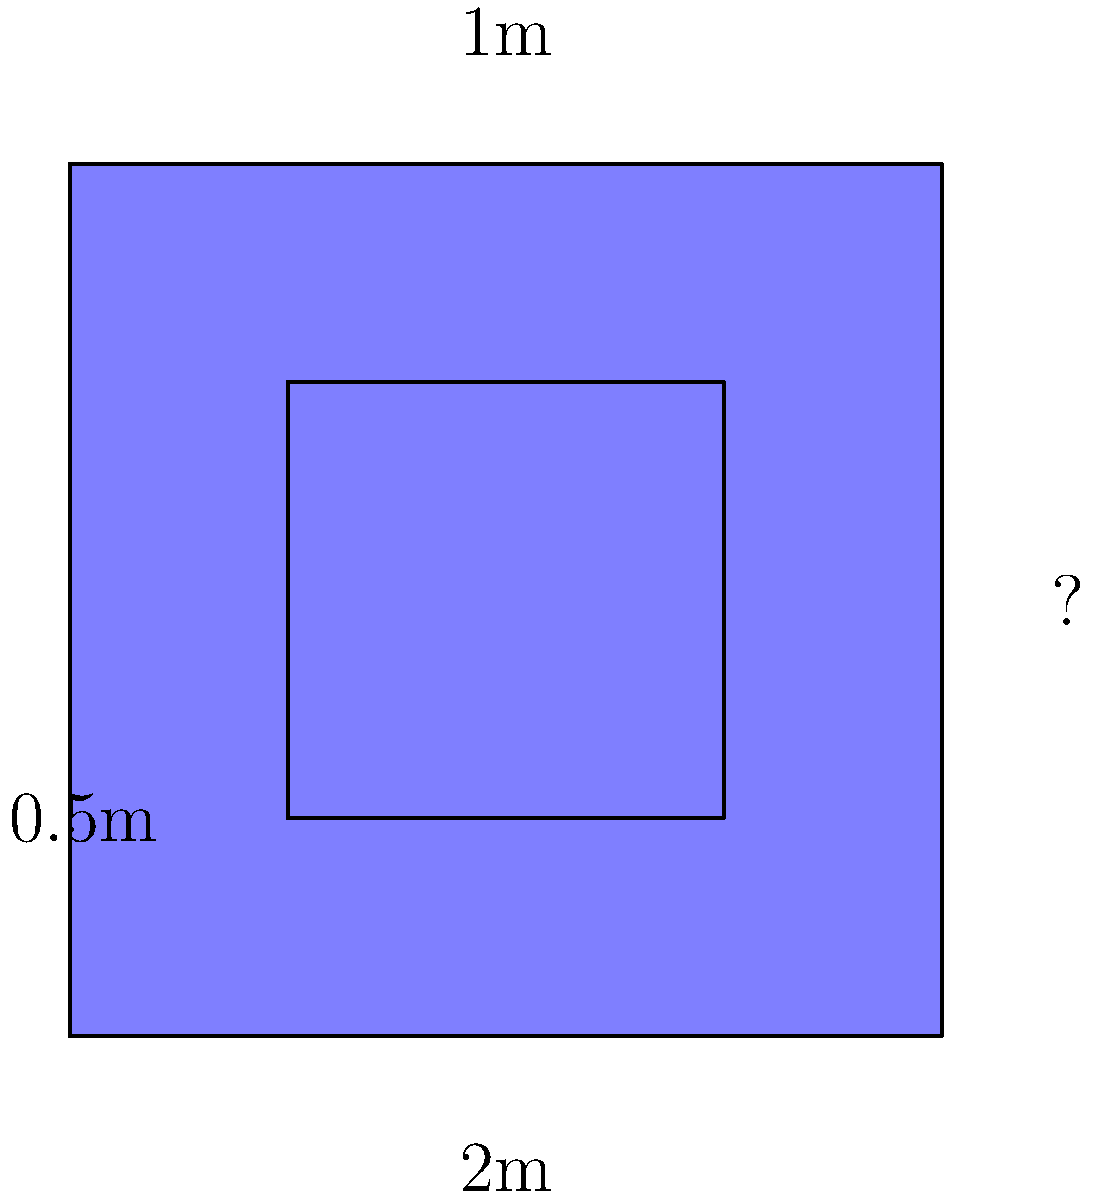A Windows enthusiast (despite your better judgment) wants to build a Windows logo-shaped swimming pool. The outer square has a width of 2m, and the inner square's side length is half that of the outer square. If the pool's depth is 1m, what is the perimeter of this unfortunate design choice? Let's approach this step-by-step:

1) First, we need to find the missing side length of the outer square:
   We're given that the width is 2m, so the height must also be 2m (as it's a square).

2) Now, let's calculate the perimeter of the outer square:
   $P_{outer} = 4 \times 2m = 8m$

3) For the inner square:
   We're told its side length is half of the outer square's.
   $Side_{inner} = \frac{1}{2} \times 2m = 1m$

4) Calculate the perimeter of the inner square:
   $P_{inner} = 4 \times 1m = 4m$

5) The total perimeter is the sum of both perimeters:
   $P_{total} = P_{outer} + P_{inner} = 8m + 4m = 12m$

Thus, the total perimeter of this Windows logo-shaped pool is 12m.
Answer: 12m 